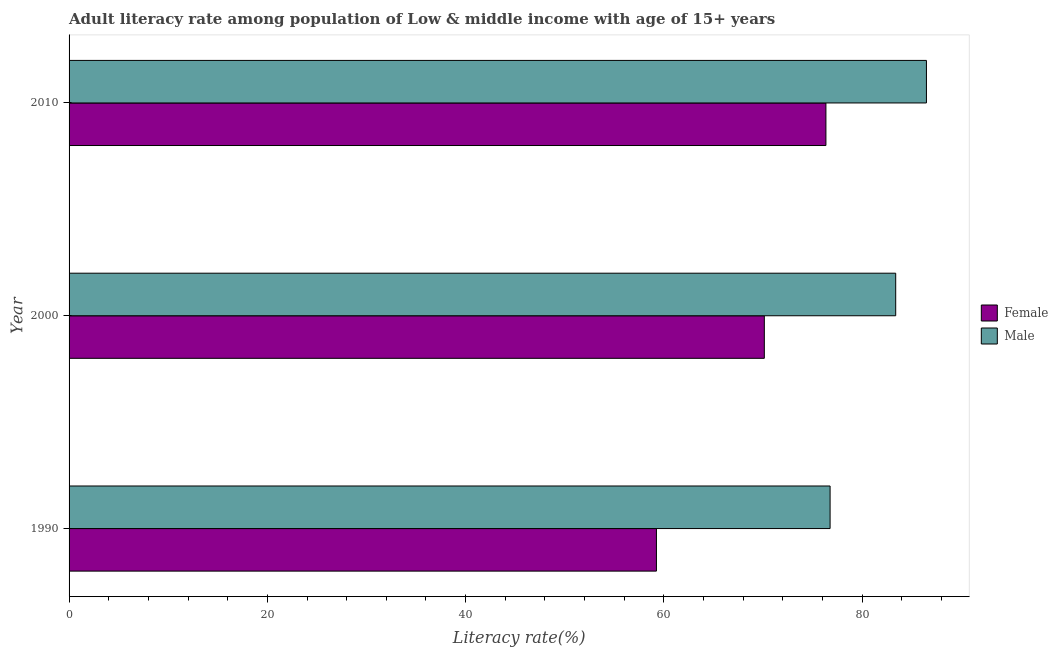How many different coloured bars are there?
Offer a terse response. 2. Are the number of bars per tick equal to the number of legend labels?
Your answer should be compact. Yes. How many bars are there on the 1st tick from the top?
Provide a short and direct response. 2. How many bars are there on the 3rd tick from the bottom?
Offer a very short reply. 2. In how many cases, is the number of bars for a given year not equal to the number of legend labels?
Offer a very short reply. 0. What is the male adult literacy rate in 2010?
Make the answer very short. 86.48. Across all years, what is the maximum female adult literacy rate?
Provide a succinct answer. 76.34. Across all years, what is the minimum female adult literacy rate?
Provide a succinct answer. 59.25. In which year was the male adult literacy rate minimum?
Provide a short and direct response. 1990. What is the total female adult literacy rate in the graph?
Offer a very short reply. 205.72. What is the difference between the female adult literacy rate in 2000 and that in 2010?
Ensure brevity in your answer.  -6.21. What is the difference between the male adult literacy rate in 2000 and the female adult literacy rate in 1990?
Your response must be concise. 24.13. What is the average female adult literacy rate per year?
Your answer should be compact. 68.57. In the year 2010, what is the difference between the female adult literacy rate and male adult literacy rate?
Ensure brevity in your answer.  -10.14. What is the ratio of the female adult literacy rate in 1990 to that in 2000?
Offer a very short reply. 0.84. Is the difference between the female adult literacy rate in 2000 and 2010 greater than the difference between the male adult literacy rate in 2000 and 2010?
Give a very brief answer. No. What is the difference between the highest and the second highest female adult literacy rate?
Keep it short and to the point. 6.21. What does the 1st bar from the top in 2010 represents?
Your answer should be very brief. Male. What is the difference between two consecutive major ticks on the X-axis?
Keep it short and to the point. 20. Does the graph contain grids?
Your answer should be compact. No. How are the legend labels stacked?
Your response must be concise. Vertical. What is the title of the graph?
Provide a succinct answer. Adult literacy rate among population of Low & middle income with age of 15+ years. Does "Methane" appear as one of the legend labels in the graph?
Your answer should be very brief. No. What is the label or title of the X-axis?
Your answer should be very brief. Literacy rate(%). What is the label or title of the Y-axis?
Ensure brevity in your answer.  Year. What is the Literacy rate(%) of Female in 1990?
Your answer should be very brief. 59.25. What is the Literacy rate(%) in Male in 1990?
Your answer should be very brief. 76.76. What is the Literacy rate(%) of Female in 2000?
Provide a short and direct response. 70.13. What is the Literacy rate(%) of Male in 2000?
Provide a short and direct response. 83.38. What is the Literacy rate(%) of Female in 2010?
Ensure brevity in your answer.  76.34. What is the Literacy rate(%) in Male in 2010?
Ensure brevity in your answer.  86.48. Across all years, what is the maximum Literacy rate(%) of Female?
Ensure brevity in your answer.  76.34. Across all years, what is the maximum Literacy rate(%) in Male?
Provide a succinct answer. 86.48. Across all years, what is the minimum Literacy rate(%) in Female?
Provide a short and direct response. 59.25. Across all years, what is the minimum Literacy rate(%) in Male?
Offer a terse response. 76.76. What is the total Literacy rate(%) in Female in the graph?
Make the answer very short. 205.72. What is the total Literacy rate(%) in Male in the graph?
Make the answer very short. 246.63. What is the difference between the Literacy rate(%) in Female in 1990 and that in 2000?
Offer a very short reply. -10.88. What is the difference between the Literacy rate(%) of Male in 1990 and that in 2000?
Provide a short and direct response. -6.62. What is the difference between the Literacy rate(%) in Female in 1990 and that in 2010?
Provide a short and direct response. -17.1. What is the difference between the Literacy rate(%) in Male in 1990 and that in 2010?
Ensure brevity in your answer.  -9.72. What is the difference between the Literacy rate(%) of Female in 2000 and that in 2010?
Offer a terse response. -6.21. What is the difference between the Literacy rate(%) in Male in 2000 and that in 2010?
Offer a terse response. -3.1. What is the difference between the Literacy rate(%) of Female in 1990 and the Literacy rate(%) of Male in 2000?
Your answer should be compact. -24.13. What is the difference between the Literacy rate(%) in Female in 1990 and the Literacy rate(%) in Male in 2010?
Keep it short and to the point. -27.24. What is the difference between the Literacy rate(%) in Female in 2000 and the Literacy rate(%) in Male in 2010?
Your response must be concise. -16.35. What is the average Literacy rate(%) in Female per year?
Keep it short and to the point. 68.57. What is the average Literacy rate(%) in Male per year?
Your answer should be compact. 82.21. In the year 1990, what is the difference between the Literacy rate(%) in Female and Literacy rate(%) in Male?
Your answer should be compact. -17.52. In the year 2000, what is the difference between the Literacy rate(%) in Female and Literacy rate(%) in Male?
Provide a short and direct response. -13.25. In the year 2010, what is the difference between the Literacy rate(%) in Female and Literacy rate(%) in Male?
Provide a short and direct response. -10.14. What is the ratio of the Literacy rate(%) in Female in 1990 to that in 2000?
Provide a short and direct response. 0.84. What is the ratio of the Literacy rate(%) in Male in 1990 to that in 2000?
Provide a short and direct response. 0.92. What is the ratio of the Literacy rate(%) in Female in 1990 to that in 2010?
Your response must be concise. 0.78. What is the ratio of the Literacy rate(%) in Male in 1990 to that in 2010?
Provide a succinct answer. 0.89. What is the ratio of the Literacy rate(%) of Female in 2000 to that in 2010?
Make the answer very short. 0.92. What is the ratio of the Literacy rate(%) of Male in 2000 to that in 2010?
Keep it short and to the point. 0.96. What is the difference between the highest and the second highest Literacy rate(%) of Female?
Provide a short and direct response. 6.21. What is the difference between the highest and the second highest Literacy rate(%) in Male?
Offer a terse response. 3.1. What is the difference between the highest and the lowest Literacy rate(%) of Female?
Your response must be concise. 17.1. What is the difference between the highest and the lowest Literacy rate(%) in Male?
Your answer should be compact. 9.72. 